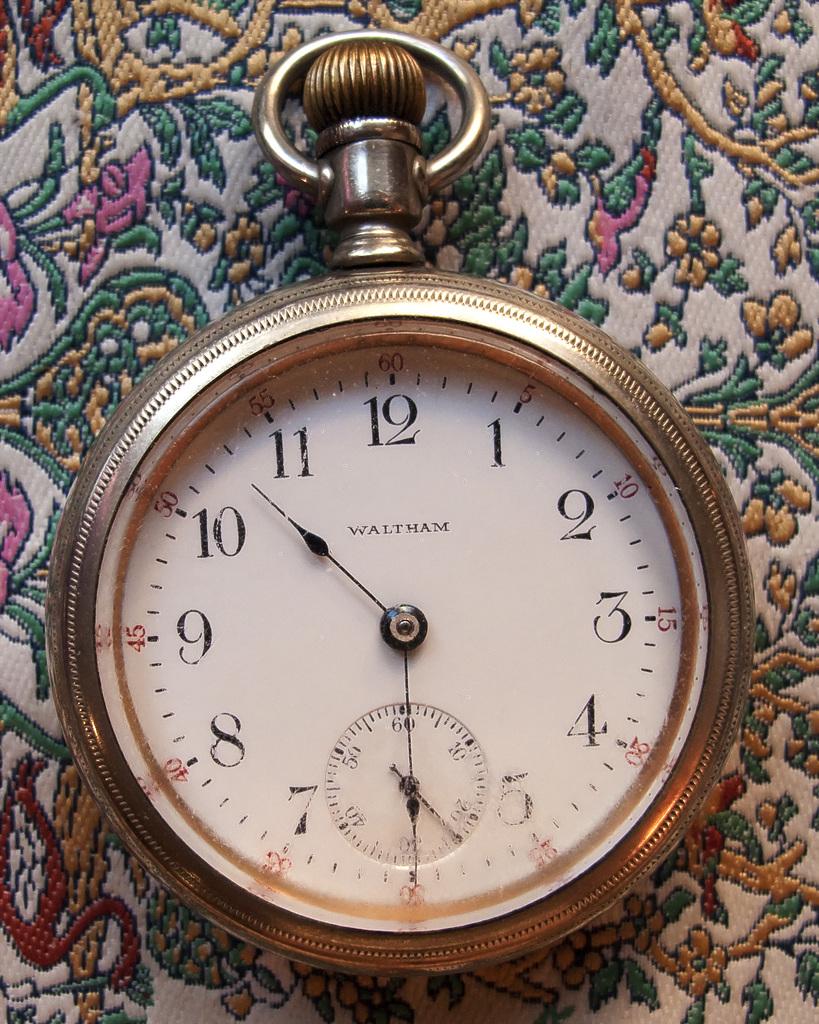What time is it?
Provide a succinct answer. 10:30. What number is on the top?
Offer a very short reply. 12. 